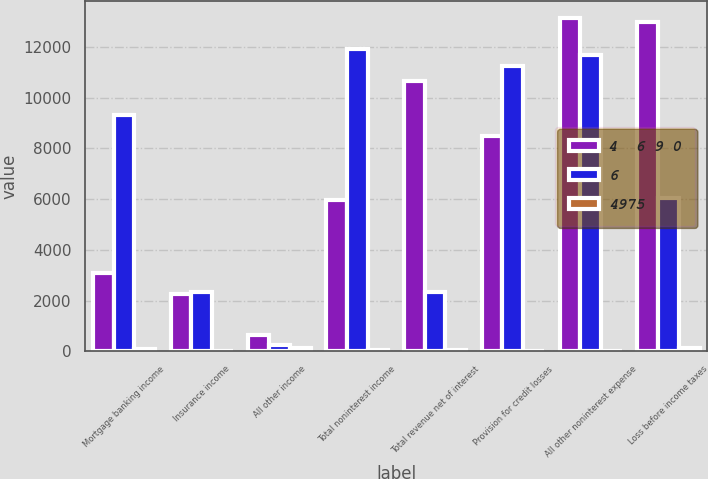Convert chart to OTSL. <chart><loc_0><loc_0><loc_500><loc_500><stacked_bar_chart><ecel><fcel>Mortgage banking income<fcel>Insurance income<fcel>All other income<fcel>Total noninterest income<fcel>Total revenue net of interest<fcel>Provision for credit losses<fcel>All other noninterest expense<fcel>Loss before income taxes<nl><fcel>4  6 9 0<fcel>3079<fcel>2257<fcel>621<fcel>5957<fcel>10647<fcel>8490<fcel>13163<fcel>13006<nl><fcel>6<fcel>9321<fcel>2346<fcel>261<fcel>11928<fcel>2346<fcel>11244<fcel>11705<fcel>6046<nl><fcel>4975<fcel>67<fcel>4<fcel>138<fcel>50<fcel>37<fcel>24<fcel>12<fcel>115<nl></chart> 